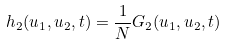<formula> <loc_0><loc_0><loc_500><loc_500>h _ { 2 } ( u _ { 1 } , u _ { 2 } , t ) = \frac { 1 } { N } G _ { 2 } ( u _ { 1 } , u _ { 2 } , t )</formula> 